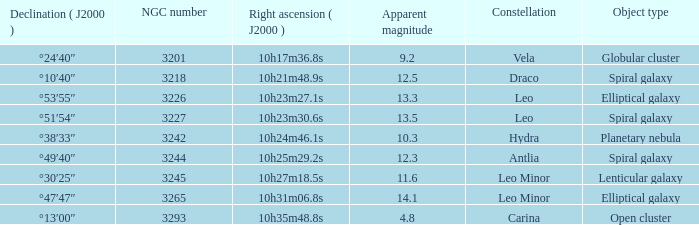What is the Apparent magnitude of a globular cluster? 9.2. 